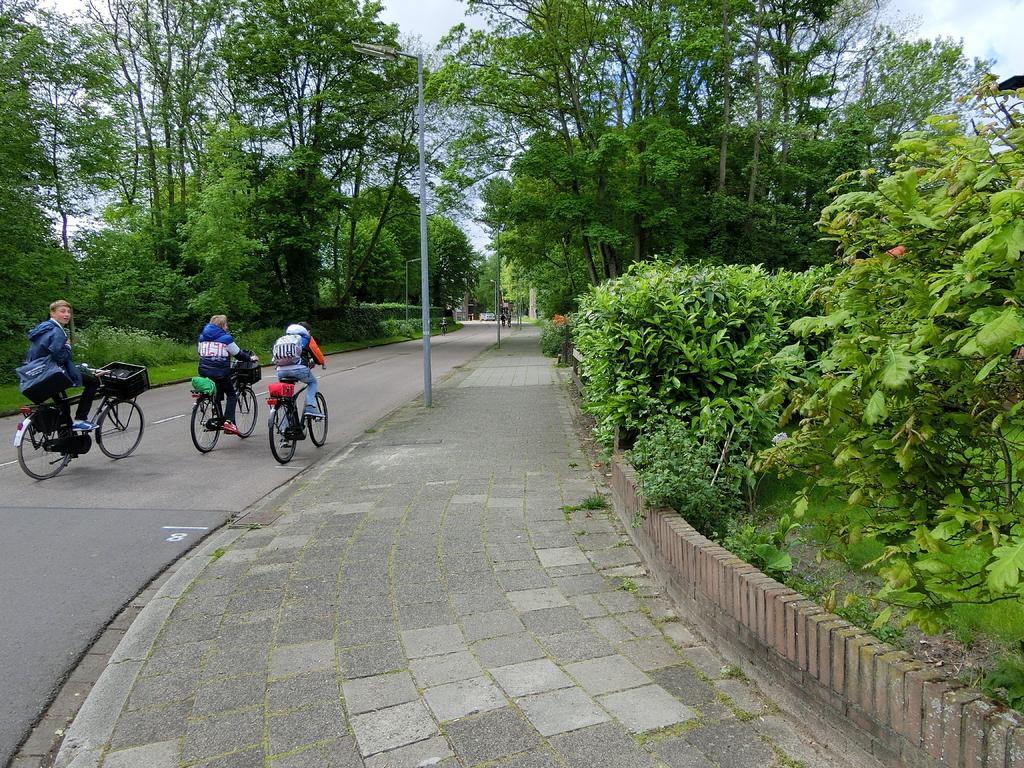What is the main feature of the image? There is a road in the image. What are the people on the road doing? There are people sitting on bicycles on the road. What can be seen in the background of the image? There are trees visible in the image. What else can be seen in the image besides the road and trees? There are poles in the image. What is visible in the sky in the background of the image? The sky is visible in the background of the image. What type of shoes can be seen on the berry in the image? There is no berry present in the image, and therefore no shoes can be seen on it. 